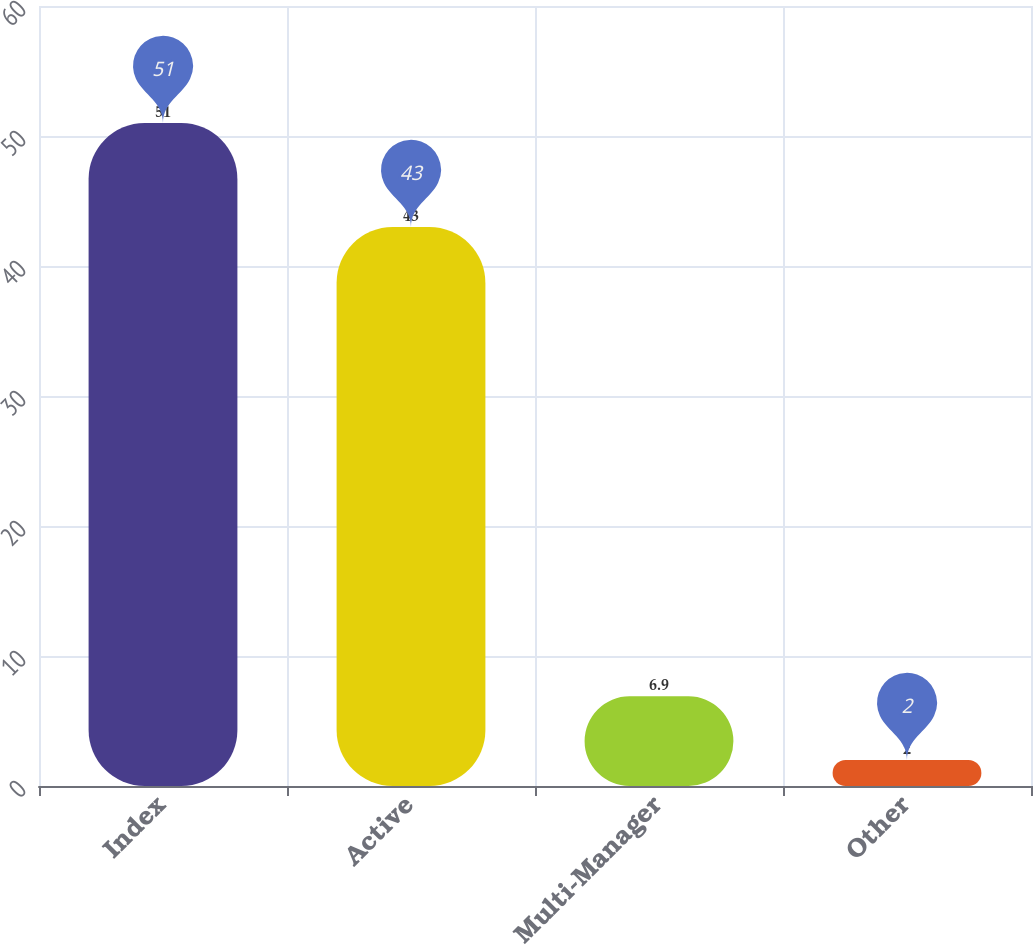Convert chart to OTSL. <chart><loc_0><loc_0><loc_500><loc_500><bar_chart><fcel>Index<fcel>Active<fcel>Multi-Manager<fcel>Other<nl><fcel>51<fcel>43<fcel>6.9<fcel>2<nl></chart> 